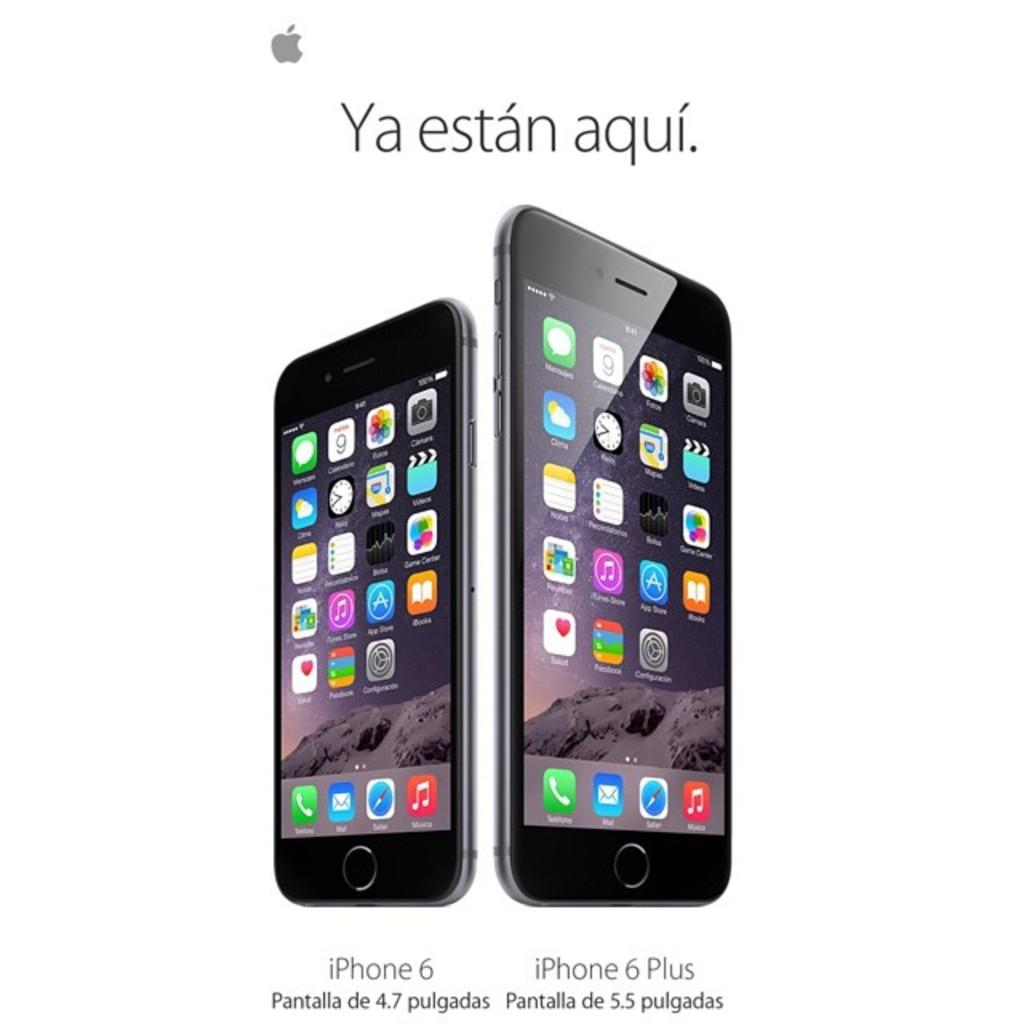<image>
Present a compact description of the photo's key features. An advertisement for the iphone six and the iphone six plus standing side by side. 